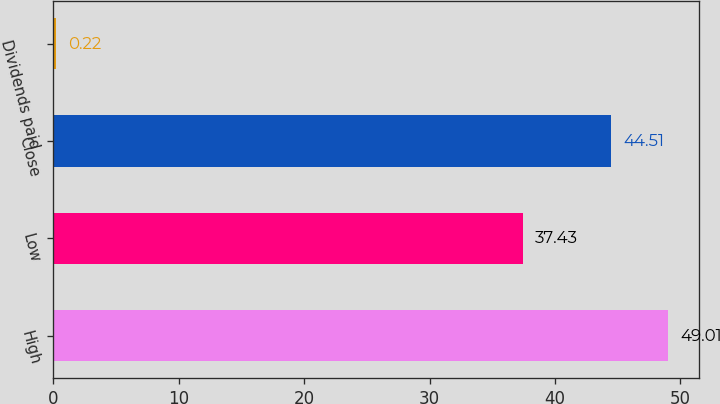Convert chart to OTSL. <chart><loc_0><loc_0><loc_500><loc_500><bar_chart><fcel>High<fcel>Low<fcel>Close<fcel>Dividends paid<nl><fcel>49.01<fcel>37.43<fcel>44.51<fcel>0.22<nl></chart> 